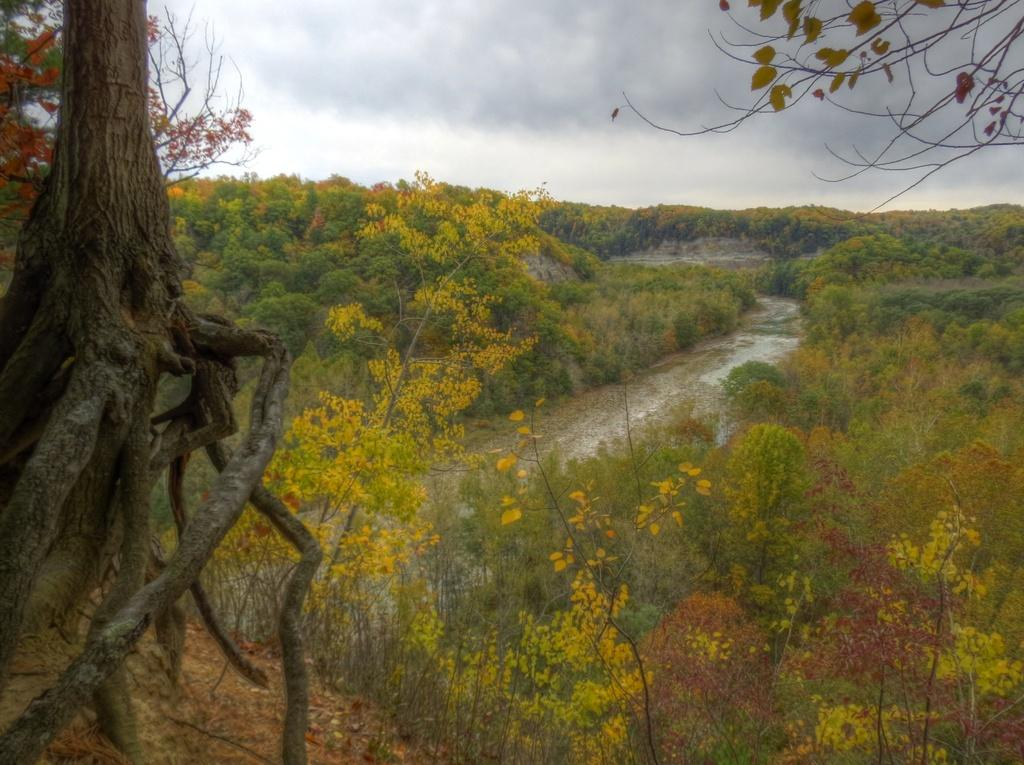What type of vegetation can be seen in the image? There are trees and plants in the image. What natural element is visible in the image? Water is visible in the image. What is visible in the background of the image? The sky is visible in the background of the image. How would you describe the sky in the image? The sky appears to be cloudy in the image. What type of card is being used to measure the pollution levels in the image? There is no card or apparatus for measuring pollution levels present in the image. 